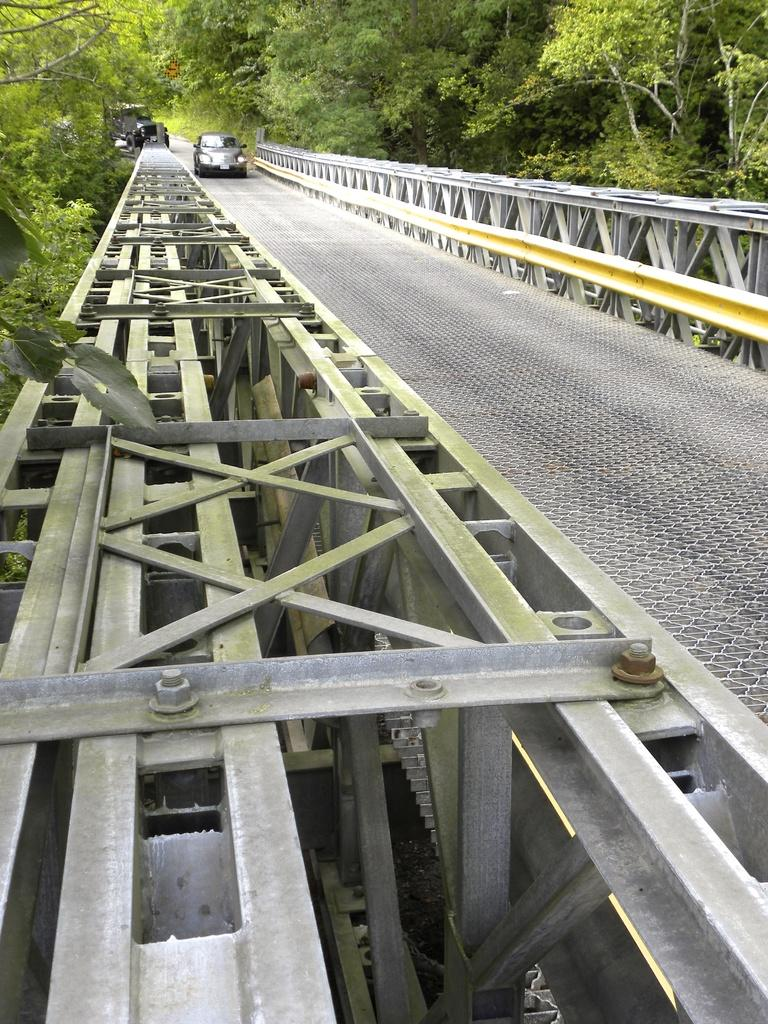What structure can be seen in the image? There is a bridge in the image. How many vehicles are present in the image? There are 2 vehicles in the image. What type of natural elements can be seen in the image? There are trees visible in the image. What additional objects can be seen in the image? There are rods present in the image. What type of salt is being used to season the liquid in the image? There is no salt or liquid present in the image; it features a bridge, vehicles, trees, and rods. 